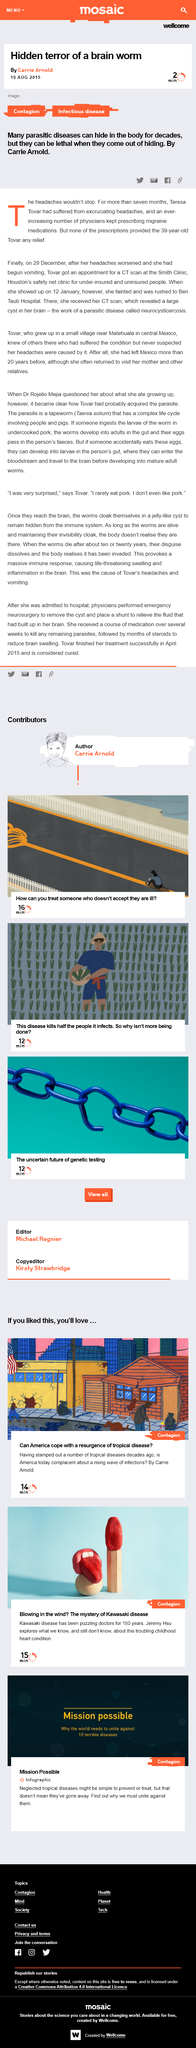Outline some significant characteristics in this image. Neurocysticercosis can be misdiagnosed as migraines due to the prevalence of headaches in both conditions, leading physicians to mistakenly assume that the patient is experiencing migraines. Neurocysticerosis is a condition characterized by the formation of brain cysts, which can result in excruciating headaches that persist for an extended period of time. The signs and symptoms of neurocysticerosis include severe, chronic headaches, difficulty with balance and coordination, and vision disturbances. Cysts on the brain can be revealed through a CT scan, as they can be visualized on images obtained through this diagnostic procedure. 